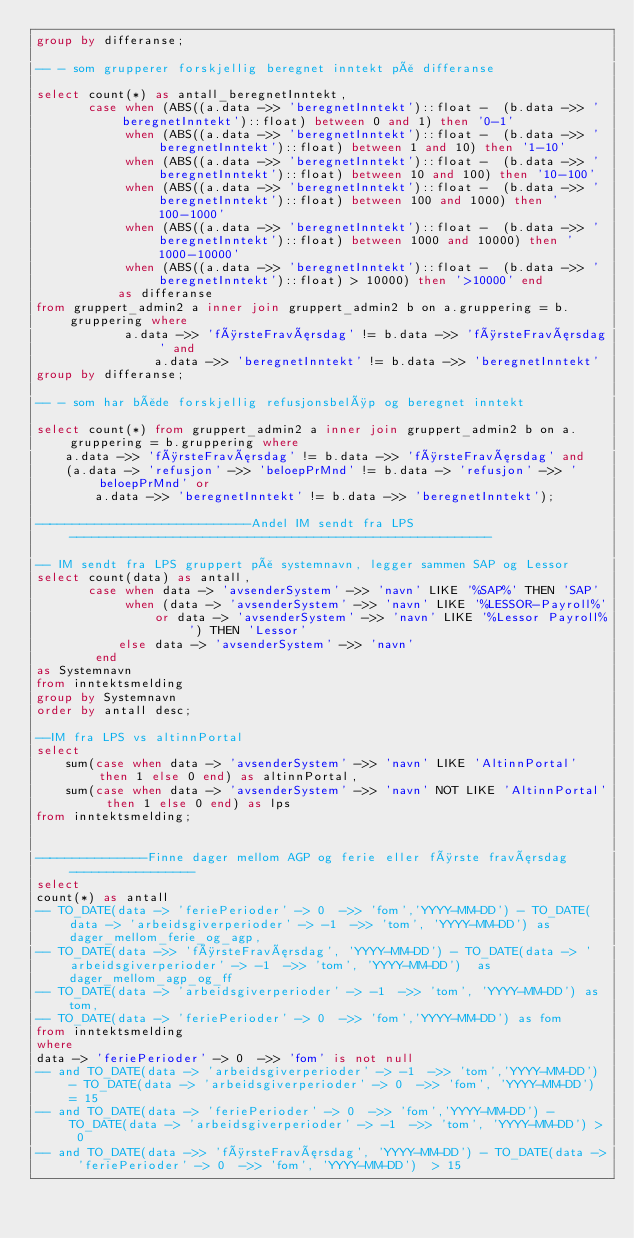<code> <loc_0><loc_0><loc_500><loc_500><_SQL_>group by differanse;

-- - som grupperer forskjellig beregnet inntekt på differanse

select count(*) as antall_beregnetInntekt,
       case when (ABS((a.data ->> 'beregnetInntekt')::float -  (b.data ->> 'beregnetInntekt')::float) between 0 and 1) then '0-1'
            when (ABS((a.data ->> 'beregnetInntekt')::float -  (b.data ->> 'beregnetInntekt')::float) between 1 and 10) then '1-10'
            when (ABS((a.data ->> 'beregnetInntekt')::float -  (b.data ->> 'beregnetInntekt')::float) between 10 and 100) then '10-100'
            when (ABS((a.data ->> 'beregnetInntekt')::float -  (b.data ->> 'beregnetInntekt')::float) between 100 and 1000) then '100-1000'
            when (ABS((a.data ->> 'beregnetInntekt')::float -  (b.data ->> 'beregnetInntekt')::float) between 1000 and 10000) then '1000-10000'
            when (ABS((a.data ->> 'beregnetInntekt')::float -  (b.data ->> 'beregnetInntekt')::float) > 10000) then '>10000' end
           as differanse
from gruppert_admin2 a inner join gruppert_admin2 b on a.gruppering = b.gruppering where
            a.data ->> 'førsteFraværsdag' != b.data ->> 'førsteFraværsdag' and
                a.data ->> 'beregnetInntekt' != b.data ->> 'beregnetInntekt'
group by differanse;

-- - som har både forskjellig refusjonsbeløp og beregnet inntekt

select count(*) from gruppert_admin2 a inner join gruppert_admin2 b on a.gruppering = b.gruppering where
    a.data ->> 'førsteFraværsdag' != b.data ->> 'førsteFraværsdag' and
    (a.data -> 'refusjon' ->> 'beloepPrMnd' != b.data -> 'refusjon' ->> 'beloepPrMnd' or
        a.data ->> 'beregnetInntekt' != b.data ->> 'beregnetInntekt');

-----------------------------Andel IM sendt fra LPS---------------------------------------------------------

-- IM sendt fra LPS gruppert på systemnavn, legger sammen SAP og Lessor
select count(data) as antall,
       case when data -> 'avsenderSystem' ->> 'navn' LIKE '%SAP%' THEN 'SAP'
            when (data -> 'avsenderSystem' ->> 'navn' LIKE '%LESSOR-Payroll%'
                or data -> 'avsenderSystem' ->> 'navn' LIKE '%Lessor Payroll%') THEN 'Lessor'
           else data -> 'avsenderSystem' ->> 'navn'
        end
as Systemnavn
from inntektsmelding
group by Systemnavn
order by antall desc;

--IM fra LPS vs altinnPortal
select
    sum(case when data -> 'avsenderSystem' ->> 'navn' LIKE 'AltinnPortal' then 1 else 0 end) as altinnPortal,
    sum(case when data -> 'avsenderSystem' ->> 'navn' NOT LIKE 'AltinnPortal' then 1 else 0 end) as lps
from inntektsmelding;


---------------Finne dager mellom AGP og ferie eller første fraværsdag-----------------
select
count(*) as antall
-- TO_DATE(data -> 'feriePerioder' -> 0  ->> 'fom','YYYY-MM-DD') - TO_DATE(data -> 'arbeidsgiverperioder' -> -1  ->> 'tom', 'YYYY-MM-DD') as dager_mellom_ferie_og_agp,
-- TO_DATE(data ->> 'førsteFraværsdag', 'YYYY-MM-DD') - TO_DATE(data -> 'arbeidsgiverperioder' -> -1  ->> 'tom', 'YYYY-MM-DD')  as dager_mellom_agp_og_ff
-- TO_DATE(data -> 'arbeidsgiverperioder' -> -1  ->> 'tom', 'YYYY-MM-DD') as tom,
-- TO_DATE(data -> 'feriePerioder' -> 0  ->> 'fom','YYYY-MM-DD') as fom
from inntektsmelding
where
data -> 'feriePerioder' -> 0  ->> 'fom' is not null
-- and TO_DATE(data -> 'arbeidsgiverperioder' -> -1  ->> 'tom','YYYY-MM-DD') - TO_DATE(data -> 'arbeidsgiverperioder' -> 0  ->> 'fom', 'YYYY-MM-DD') = 15
-- and TO_DATE(data -> 'feriePerioder' -> 0  ->> 'fom','YYYY-MM-DD') - TO_DATE(data -> 'arbeidsgiverperioder' -> -1  ->> 'tom', 'YYYY-MM-DD') > 0
-- and TO_DATE(data ->> 'førsteFraværsdag', 'YYYY-MM-DD') - TO_DATE(data -> 'feriePerioder' -> 0  ->> 'fom', 'YYYY-MM-DD')  > 15</code> 